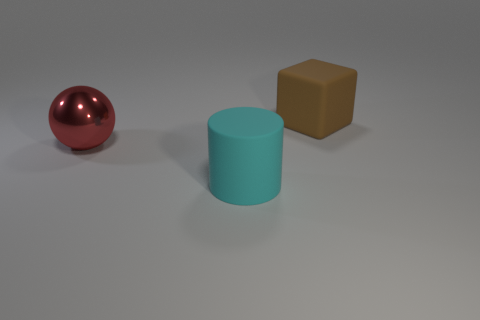Is there anything else that is made of the same material as the sphere?
Your answer should be compact. No. What is the material of the red thing that is the same size as the cube?
Offer a terse response. Metal. What number of other things are the same size as the ball?
Ensure brevity in your answer.  2. The big metal thing is what shape?
Your response must be concise. Sphere. What color is the large thing that is behind the cyan cylinder and in front of the large rubber cube?
Provide a short and direct response. Red. What is the material of the big red sphere?
Give a very brief answer. Metal. What is the shape of the rubber object that is in front of the red shiny object?
Provide a succinct answer. Cylinder. What color is the block that is the same size as the metallic thing?
Your response must be concise. Brown. Do the thing that is in front of the big red metallic object and the big red ball have the same material?
Your response must be concise. No. There is a big metal object behind the rubber thing in front of the object that is behind the red sphere; what shape is it?
Offer a terse response. Sphere. 